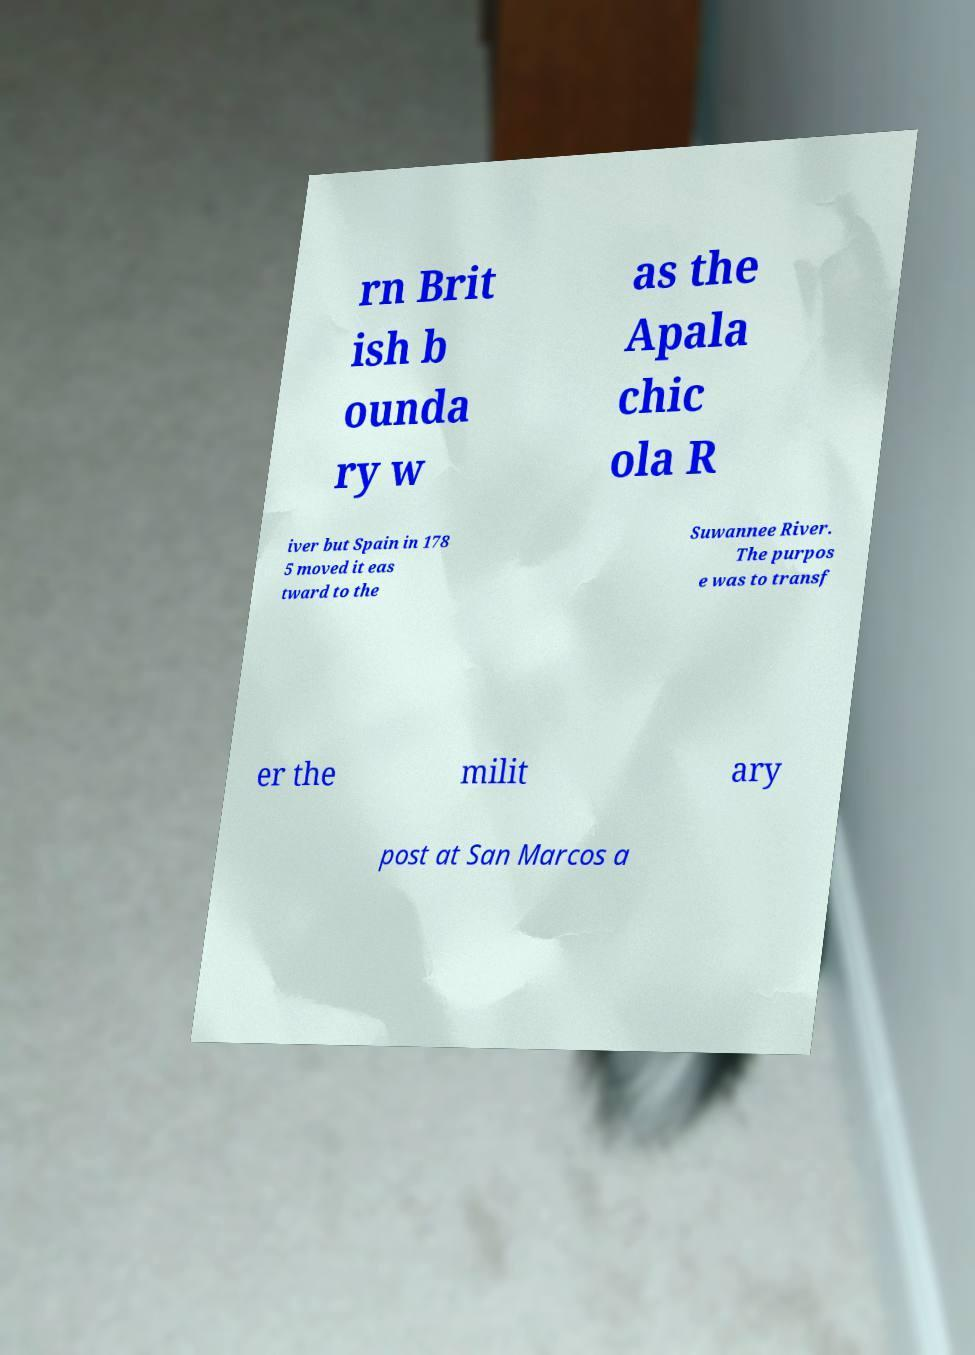Could you assist in decoding the text presented in this image and type it out clearly? rn Brit ish b ounda ry w as the Apala chic ola R iver but Spain in 178 5 moved it eas tward to the Suwannee River. The purpos e was to transf er the milit ary post at San Marcos a 